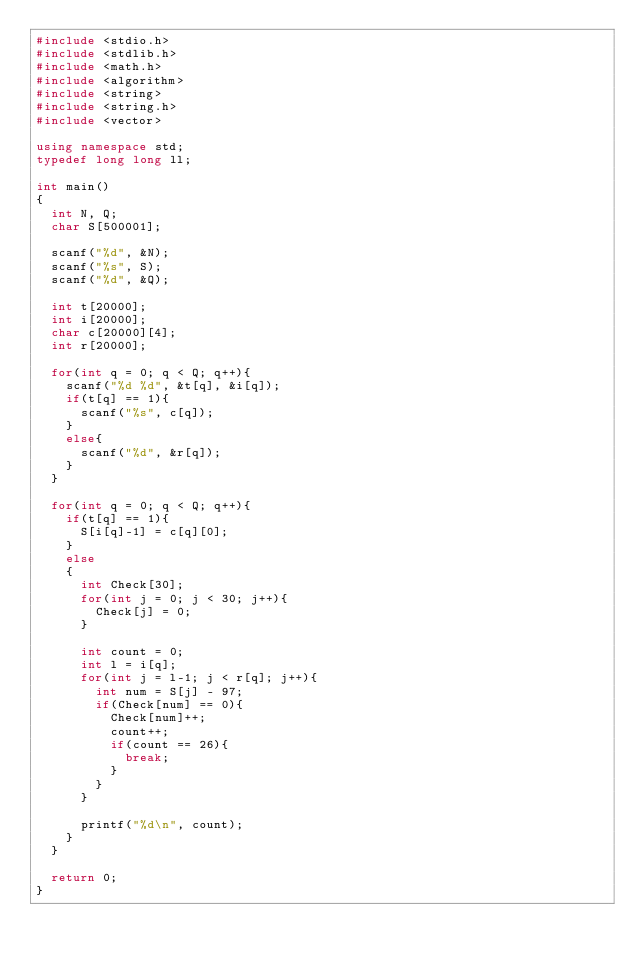Convert code to text. <code><loc_0><loc_0><loc_500><loc_500><_C++_>#include <stdio.h>
#include <stdlib.h>
#include <math.h>
#include <algorithm>
#include <string>
#include <string.h>
#include <vector>

using namespace std;
typedef long long ll;

int main()
{
	int N, Q;
	char S[500001];
	
	scanf("%d", &N);
	scanf("%s", S);
	scanf("%d", &Q);
	
	int t[20000];
	int i[20000];
	char c[20000][4];
	int r[20000];
	
	for(int q = 0; q < Q; q++){
		scanf("%d %d", &t[q], &i[q]);
		if(t[q] == 1){
			scanf("%s", c[q]);
		}
		else{
			scanf("%d", &r[q]);
		}
	}
	
	for(int q = 0; q < Q; q++){
		if(t[q] == 1){
			S[i[q]-1] = c[q][0];
		}
		else
		{
			int Check[30];
			for(int j = 0; j < 30; j++){
				Check[j] = 0;
			}
			
			int count = 0;
			int l = i[q];
			for(int j = l-1; j < r[q]; j++){
				int num = S[j] - 97;
				if(Check[num] == 0){
					Check[num]++;
					count++;
					if(count == 26){
						break;
					}
				}
			}
			
			printf("%d\n", count);
		}
	}
	
	return 0;
}</code> 